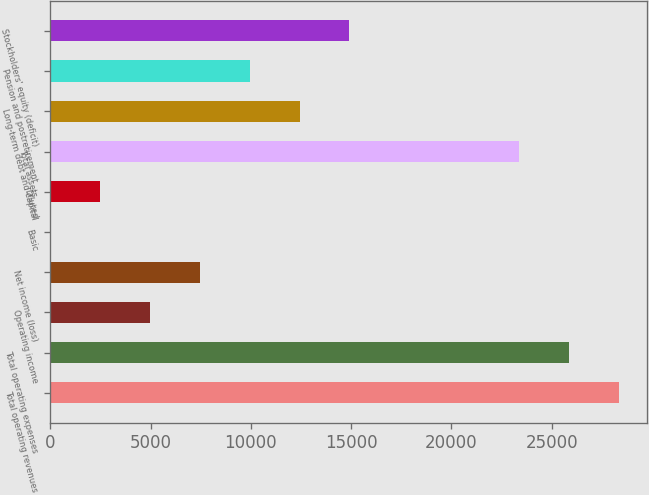Convert chart to OTSL. <chart><loc_0><loc_0><loc_500><loc_500><bar_chart><fcel>Total operating revenues<fcel>Total operating expenses<fcel>Operating income<fcel>Net income (loss)<fcel>Basic<fcel>Diluted<fcel>Total assets<fcel>Long-term debt and capital<fcel>Pension and postretirement<fcel>Stockholders' equity (deficit)<nl><fcel>28365.5<fcel>25880.8<fcel>4977.02<fcel>7461.77<fcel>7.52<fcel>2492.27<fcel>23396<fcel>12431.3<fcel>9946.52<fcel>14916<nl></chart> 